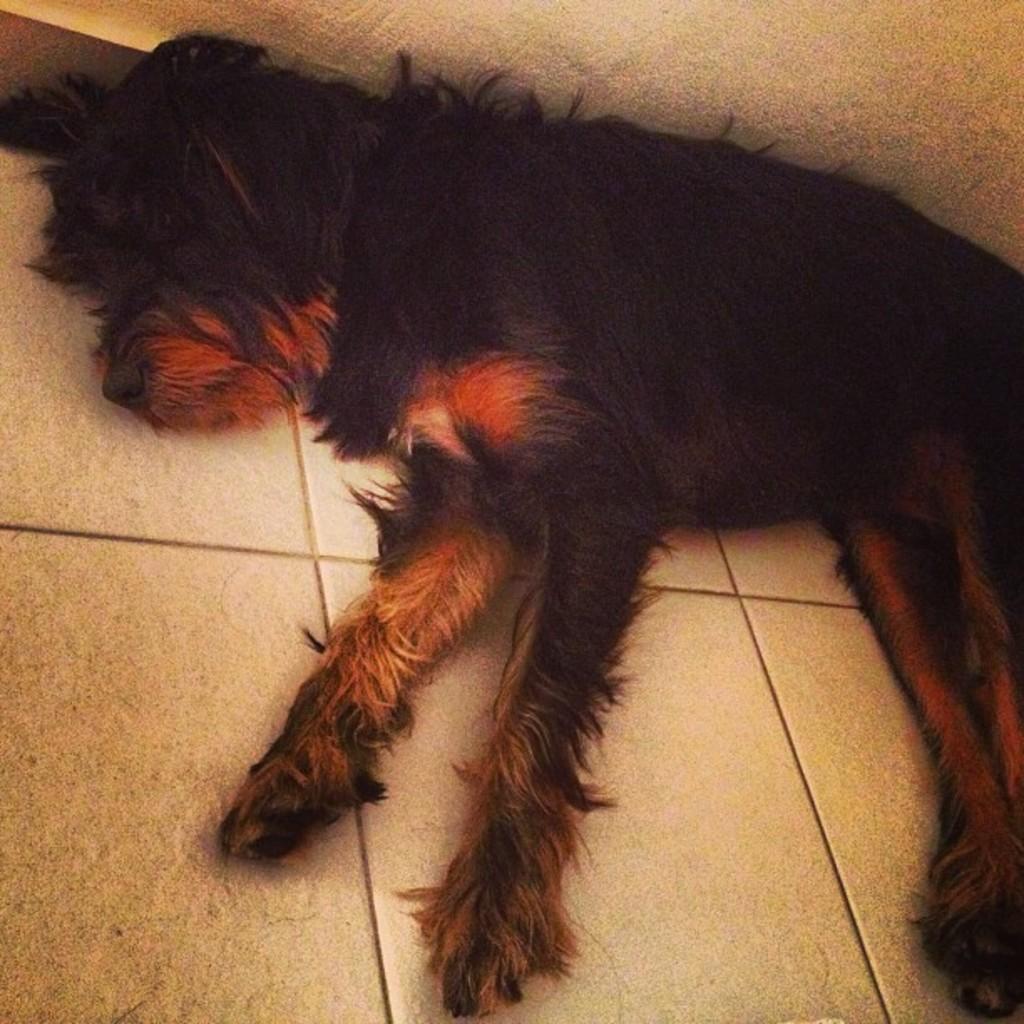Could you give a brief overview of what you see in this image? In this image we can see a dog lying on the floor. In the back there is a wall. 